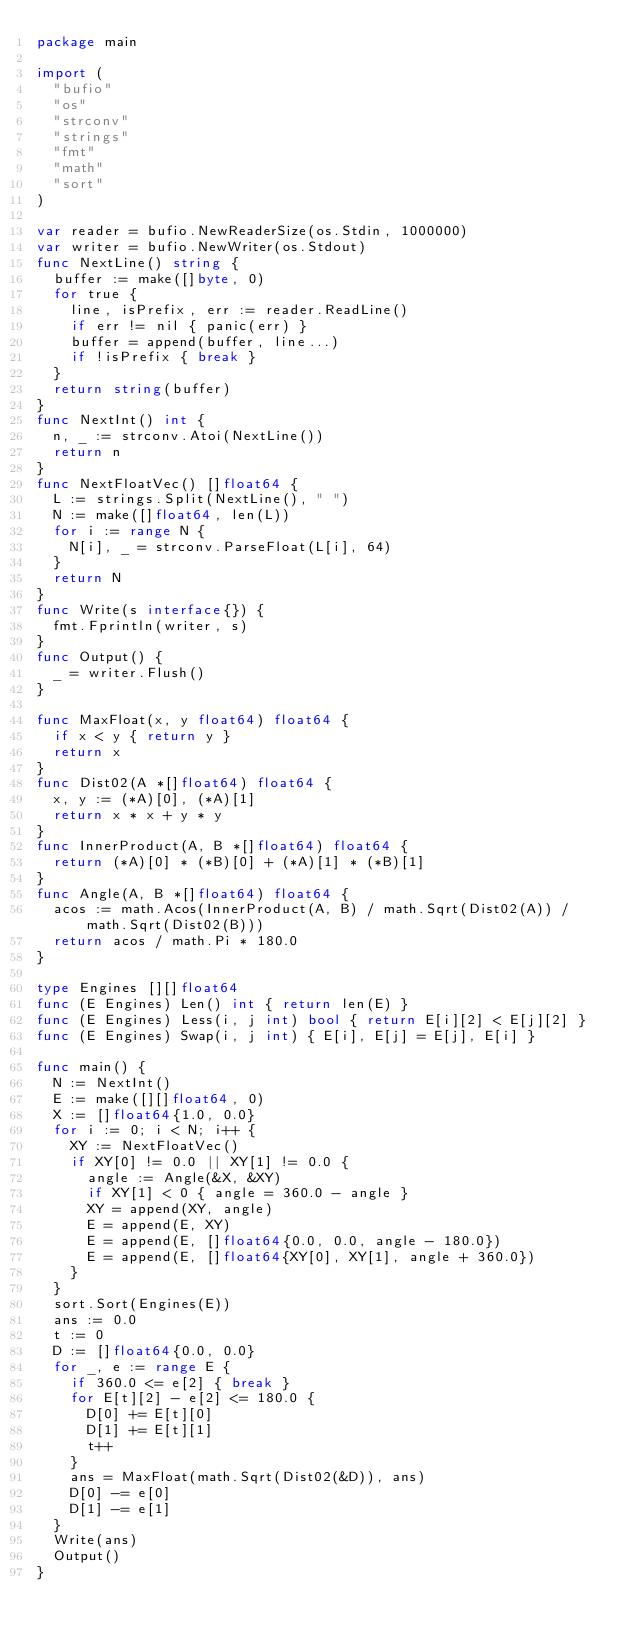<code> <loc_0><loc_0><loc_500><loc_500><_Go_>package main

import (
  "bufio"
  "os"
  "strconv"
  "strings"
  "fmt"
  "math"
  "sort"
)

var reader = bufio.NewReaderSize(os.Stdin, 1000000)
var writer = bufio.NewWriter(os.Stdout)
func NextLine() string {
  buffer := make([]byte, 0)
  for true {
    line, isPrefix, err := reader.ReadLine()
    if err != nil { panic(err) }
    buffer = append(buffer, line...)
    if !isPrefix { break }
  }
  return string(buffer)
}
func NextInt() int {
  n, _ := strconv.Atoi(NextLine())
  return n
}
func NextFloatVec() []float64 {
  L := strings.Split(NextLine(), " ")
  N := make([]float64, len(L))
  for i := range N {
    N[i], _ = strconv.ParseFloat(L[i], 64)
  }
  return N
}
func Write(s interface{}) {
  fmt.Fprintln(writer, s)
}
func Output() {
  _ = writer.Flush()
}

func MaxFloat(x, y float64) float64 {
  if x < y { return y }
  return x
}
func Dist02(A *[]float64) float64 {
  x, y := (*A)[0], (*A)[1]
  return x * x + y * y
}
func InnerProduct(A, B *[]float64) float64 {
  return (*A)[0] * (*B)[0] + (*A)[1] * (*B)[1]
}
func Angle(A, B *[]float64) float64 {
  acos := math.Acos(InnerProduct(A, B) / math.Sqrt(Dist02(A)) / math.Sqrt(Dist02(B)))
  return acos / math.Pi * 180.0
}

type Engines [][]float64
func (E Engines) Len() int { return len(E) }
func (E Engines) Less(i, j int) bool { return E[i][2] < E[j][2] }
func (E Engines) Swap(i, j int) { E[i], E[j] = E[j], E[i] }

func main() {
  N := NextInt()
  E := make([][]float64, 0)
  X := []float64{1.0, 0.0}
  for i := 0; i < N; i++ {
    XY := NextFloatVec()
    if XY[0] != 0.0 || XY[1] != 0.0 {
      angle := Angle(&X, &XY)
      if XY[1] < 0 { angle = 360.0 - angle }
      XY = append(XY, angle)
      E = append(E, XY)
      E = append(E, []float64{0.0, 0.0, angle - 180.0})
      E = append(E, []float64{XY[0], XY[1], angle + 360.0})
    }
  }
  sort.Sort(Engines(E))
  ans := 0.0
  t := 0
  D := []float64{0.0, 0.0}
  for _, e := range E {
    if 360.0 <= e[2] { break }
    for E[t][2] - e[2] <= 180.0 {
      D[0] += E[t][0]
      D[1] += E[t][1]
      t++
    }
    ans = MaxFloat(math.Sqrt(Dist02(&D)), ans)
    D[0] -= e[0]
    D[1] -= e[1]
  }
  Write(ans)
  Output()
}</code> 